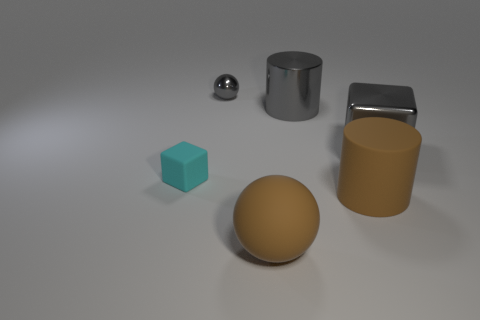What materials do the objects in the image seem to be made of? In this image, the objects appear to vary in material. The smaller sphere has a reflective metal finish, suggesting it could be steel or aluminum. The cube seems to have a matte surface, reminiscent of a turquoise-colored plastic. The larger sphere has a muted gold finish and could be a painted metal or plastic, while the cylinder standing upright appears to be a brushed metal, possibly stainless steel. Lastly, the open-ended cylinder has a plastic or rubber-like look with a slightly reflective surface. 